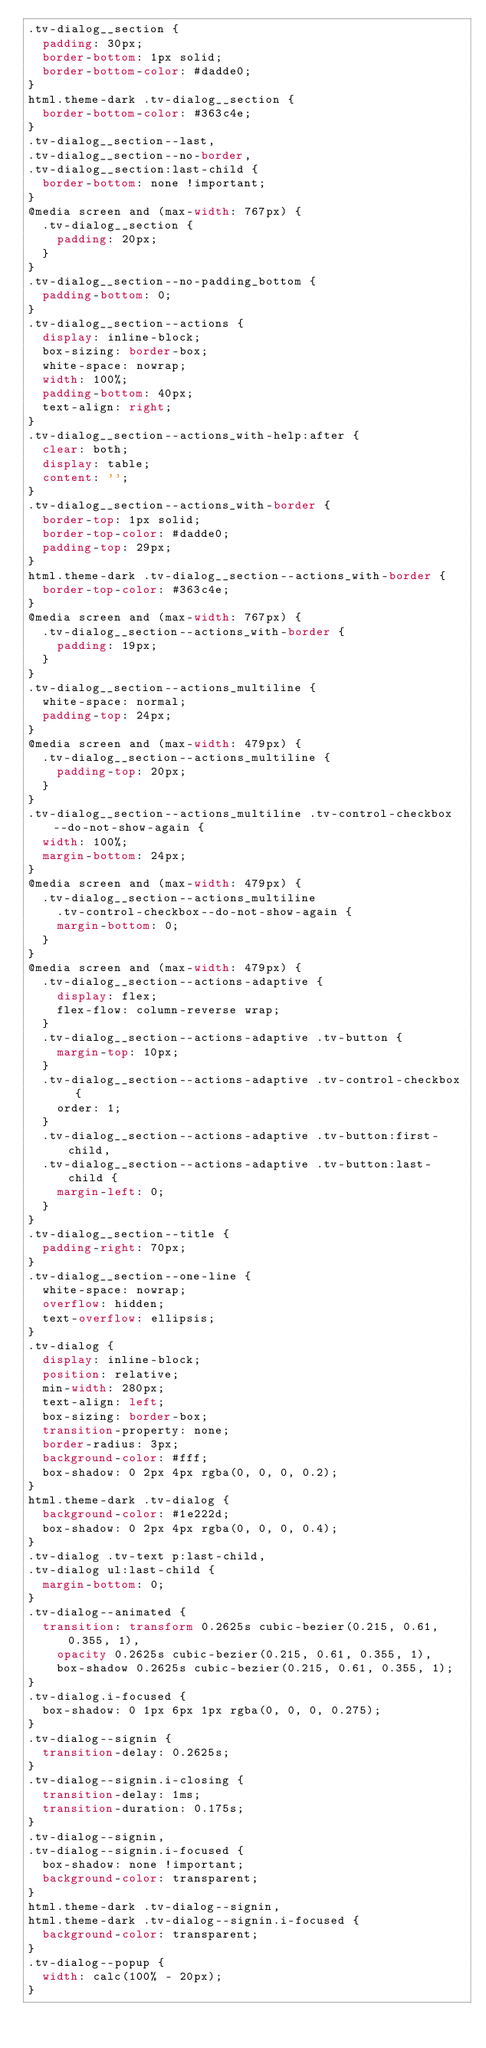<code> <loc_0><loc_0><loc_500><loc_500><_CSS_>.tv-dialog__section {
  padding: 30px;
  border-bottom: 1px solid;
  border-bottom-color: #dadde0;
}
html.theme-dark .tv-dialog__section {
  border-bottom-color: #363c4e;
}
.tv-dialog__section--last,
.tv-dialog__section--no-border,
.tv-dialog__section:last-child {
  border-bottom: none !important;
}
@media screen and (max-width: 767px) {
  .tv-dialog__section {
    padding: 20px;
  }
}
.tv-dialog__section--no-padding_bottom {
  padding-bottom: 0;
}
.tv-dialog__section--actions {
  display: inline-block;
  box-sizing: border-box;
  white-space: nowrap;
  width: 100%;
  padding-bottom: 40px;
  text-align: right;
}
.tv-dialog__section--actions_with-help:after {
  clear: both;
  display: table;
  content: '';
}
.tv-dialog__section--actions_with-border {
  border-top: 1px solid;
  border-top-color: #dadde0;
  padding-top: 29px;
}
html.theme-dark .tv-dialog__section--actions_with-border {
  border-top-color: #363c4e;
}
@media screen and (max-width: 767px) {
  .tv-dialog__section--actions_with-border {
    padding: 19px;
  }
}
.tv-dialog__section--actions_multiline {
  white-space: normal;
  padding-top: 24px;
}
@media screen and (max-width: 479px) {
  .tv-dialog__section--actions_multiline {
    padding-top: 20px;
  }
}
.tv-dialog__section--actions_multiline .tv-control-checkbox--do-not-show-again {
  width: 100%;
  margin-bottom: 24px;
}
@media screen and (max-width: 479px) {
  .tv-dialog__section--actions_multiline
    .tv-control-checkbox--do-not-show-again {
    margin-bottom: 0;
  }
}
@media screen and (max-width: 479px) {
  .tv-dialog__section--actions-adaptive {
    display: flex;
    flex-flow: column-reverse wrap;
  }
  .tv-dialog__section--actions-adaptive .tv-button {
    margin-top: 10px;
  }
  .tv-dialog__section--actions-adaptive .tv-control-checkbox {
    order: 1;
  }
  .tv-dialog__section--actions-adaptive .tv-button:first-child,
  .tv-dialog__section--actions-adaptive .tv-button:last-child {
    margin-left: 0;
  }
}
.tv-dialog__section--title {
  padding-right: 70px;
}
.tv-dialog__section--one-line {
  white-space: nowrap;
  overflow: hidden;
  text-overflow: ellipsis;
}
.tv-dialog {
  display: inline-block;
  position: relative;
  min-width: 280px;
  text-align: left;
  box-sizing: border-box;
  transition-property: none;
  border-radius: 3px;
  background-color: #fff;
  box-shadow: 0 2px 4px rgba(0, 0, 0, 0.2);
}
html.theme-dark .tv-dialog {
  background-color: #1e222d;
  box-shadow: 0 2px 4px rgba(0, 0, 0, 0.4);
}
.tv-dialog .tv-text p:last-child,
.tv-dialog ul:last-child {
  margin-bottom: 0;
}
.tv-dialog--animated {
  transition: transform 0.2625s cubic-bezier(0.215, 0.61, 0.355, 1),
    opacity 0.2625s cubic-bezier(0.215, 0.61, 0.355, 1),
    box-shadow 0.2625s cubic-bezier(0.215, 0.61, 0.355, 1);
}
.tv-dialog.i-focused {
  box-shadow: 0 1px 6px 1px rgba(0, 0, 0, 0.275);
}
.tv-dialog--signin {
  transition-delay: 0.2625s;
}
.tv-dialog--signin.i-closing {
  transition-delay: 1ms;
  transition-duration: 0.175s;
}
.tv-dialog--signin,
.tv-dialog--signin.i-focused {
  box-shadow: none !important;
  background-color: transparent;
}
html.theme-dark .tv-dialog--signin,
html.theme-dark .tv-dialog--signin.i-focused {
  background-color: transparent;
}
.tv-dialog--popup {
  width: calc(100% - 20px);
}</code> 